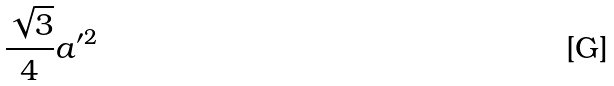Convert formula to latex. <formula><loc_0><loc_0><loc_500><loc_500>\frac { \sqrt { 3 } } { 4 } a ^ { \prime 2 }</formula> 